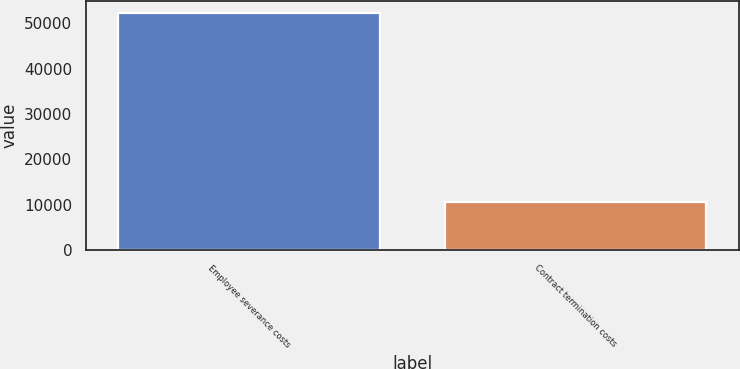Convert chart. <chart><loc_0><loc_0><loc_500><loc_500><bar_chart><fcel>Employee severance costs<fcel>Contract termination costs<nl><fcel>52344<fcel>10731<nl></chart> 